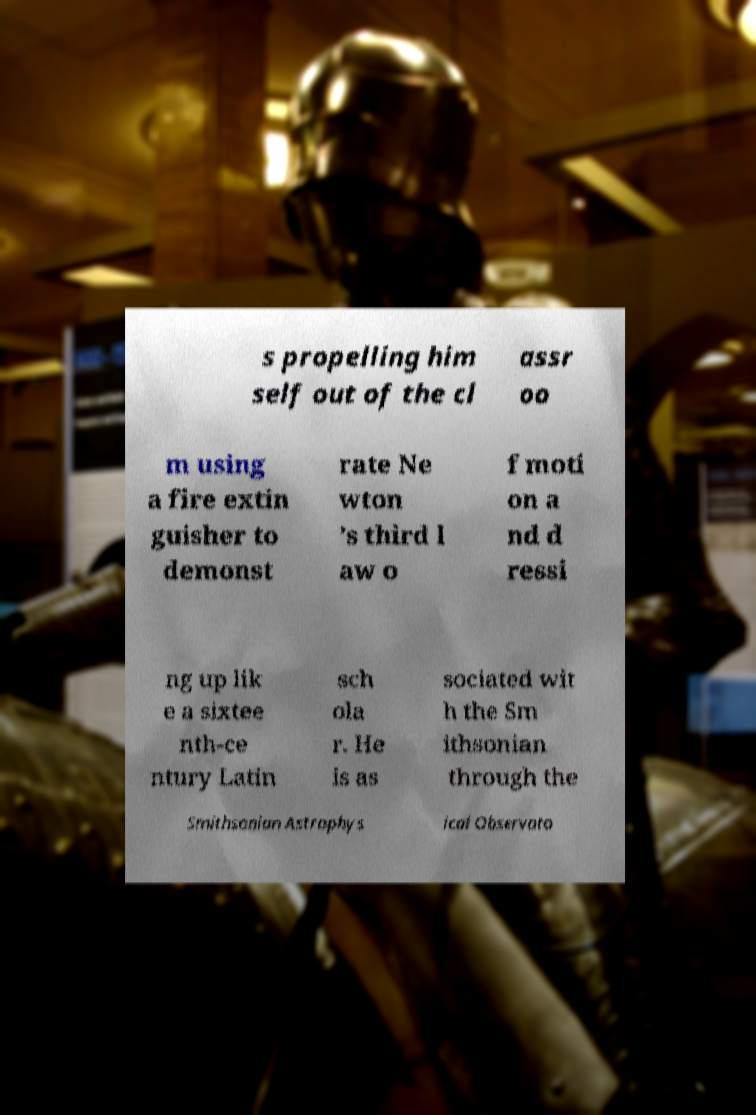There's text embedded in this image that I need extracted. Can you transcribe it verbatim? s propelling him self out of the cl assr oo m using a fire extin guisher to demonst rate Ne wton ’s third l aw o f moti on a nd d ressi ng up lik e a sixtee nth-ce ntury Latin sch ola r. He is as sociated wit h the Sm ithsonian through the Smithsonian Astrophys ical Observato 